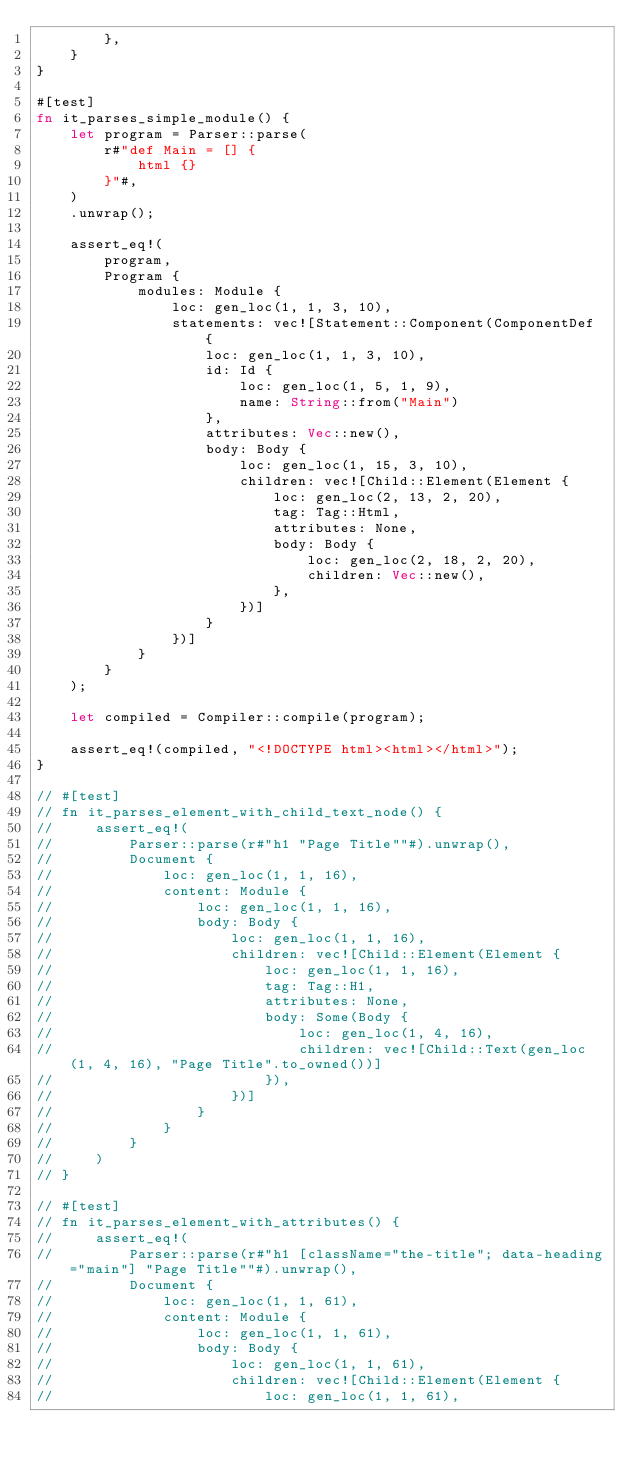<code> <loc_0><loc_0><loc_500><loc_500><_Rust_>        },
    }
}

#[test]
fn it_parses_simple_module() {
    let program = Parser::parse(
        r#"def Main = [] {
            html {}
        }"#,
    )
    .unwrap();

    assert_eq!(
        program,
        Program {
            modules: Module {
                loc: gen_loc(1, 1, 3, 10),
                statements: vec![Statement::Component(ComponentDef {
                    loc: gen_loc(1, 1, 3, 10),
                    id: Id {
                        loc: gen_loc(1, 5, 1, 9),
                        name: String::from("Main")
                    },
                    attributes: Vec::new(),
                    body: Body {
                        loc: gen_loc(1, 15, 3, 10),
                        children: vec![Child::Element(Element {
                            loc: gen_loc(2, 13, 2, 20),
                            tag: Tag::Html,
                            attributes: None,
                            body: Body {
                                loc: gen_loc(2, 18, 2, 20),
                                children: Vec::new(),
                            },
                        })]
                    }
                })]
            }
        }
    );

    let compiled = Compiler::compile(program);

    assert_eq!(compiled, "<!DOCTYPE html><html></html>");
}

// #[test]
// fn it_parses_element_with_child_text_node() {
//     assert_eq!(
//         Parser::parse(r#"h1 "Page Title""#).unwrap(),
//         Document {
//             loc: gen_loc(1, 1, 16),
//             content: Module {
//                 loc: gen_loc(1, 1, 16),
//                 body: Body {
//                     loc: gen_loc(1, 1, 16),
//                     children: vec![Child::Element(Element {
//                         loc: gen_loc(1, 1, 16),
//                         tag: Tag::H1,
//                         attributes: None,
//                         body: Some(Body {
//                             loc: gen_loc(1, 4, 16),
//                             children: vec![Child::Text(gen_loc(1, 4, 16), "Page Title".to_owned())]
//                         }),
//                     })]
//                 }
//             }
//         }
//     )
// }

// #[test]
// fn it_parses_element_with_attributes() {
//     assert_eq!(
//         Parser::parse(r#"h1 [className="the-title"; data-heading="main"] "Page Title""#).unwrap(),
//         Document {
//             loc: gen_loc(1, 1, 61),
//             content: Module {
//                 loc: gen_loc(1, 1, 61),
//                 body: Body {
//                     loc: gen_loc(1, 1, 61),
//                     children: vec![Child::Element(Element {
//                         loc: gen_loc(1, 1, 61),</code> 